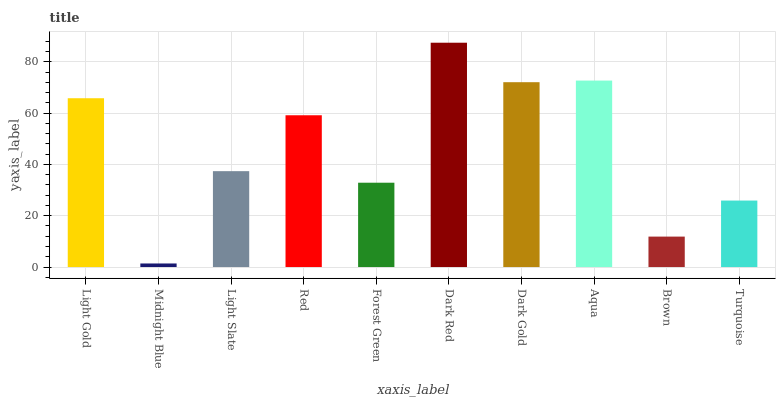Is Light Slate the minimum?
Answer yes or no. No. Is Light Slate the maximum?
Answer yes or no. No. Is Light Slate greater than Midnight Blue?
Answer yes or no. Yes. Is Midnight Blue less than Light Slate?
Answer yes or no. Yes. Is Midnight Blue greater than Light Slate?
Answer yes or no. No. Is Light Slate less than Midnight Blue?
Answer yes or no. No. Is Red the high median?
Answer yes or no. Yes. Is Light Slate the low median?
Answer yes or no. Yes. Is Turquoise the high median?
Answer yes or no. No. Is Dark Red the low median?
Answer yes or no. No. 